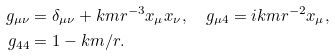<formula> <loc_0><loc_0><loc_500><loc_500>g _ { \mu \nu } & = \delta _ { \mu \nu } + k m r ^ { - 3 } x _ { \mu } x _ { \nu } , \quad g _ { \mu 4 } = i k m r ^ { - 2 } x _ { \mu } , \\ g _ { 4 4 } & = 1 - k m / r .</formula> 